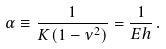Convert formula to latex. <formula><loc_0><loc_0><loc_500><loc_500>\alpha \equiv \frac { 1 } { K ( 1 - \nu ^ { 2 } ) } = \frac { 1 } { E h } \, .</formula> 